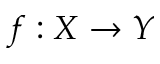<formula> <loc_0><loc_0><loc_500><loc_500>f \colon X \to Y</formula> 